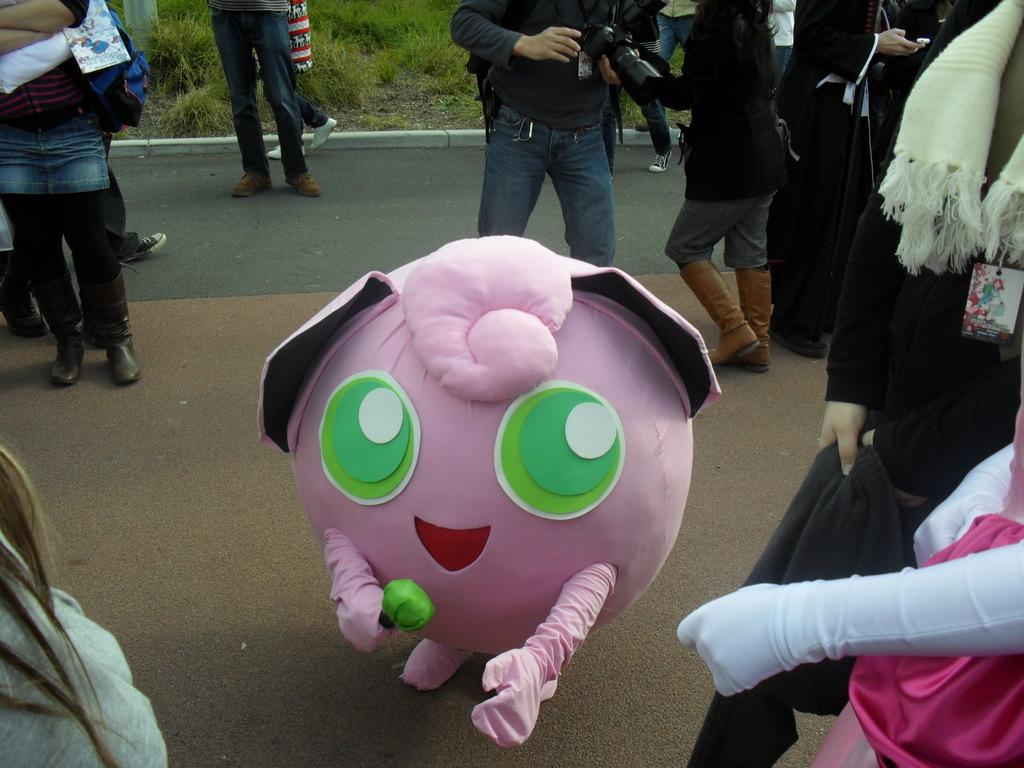What is happening in the image? There are people standing in the image. What can be seen in the background of the image? There is a road visible in the image. What type of vegetation is present on the ground in the image? There is green grass on the ground in the image. Can you see any jellyfish swimming in the grass in the image? There are no jellyfish present in the image; it features people standing on green grass. What type of branch is being used by the people in the image? There is no branch visible in the image; it only shows people standing on green grass and a road in the background. 